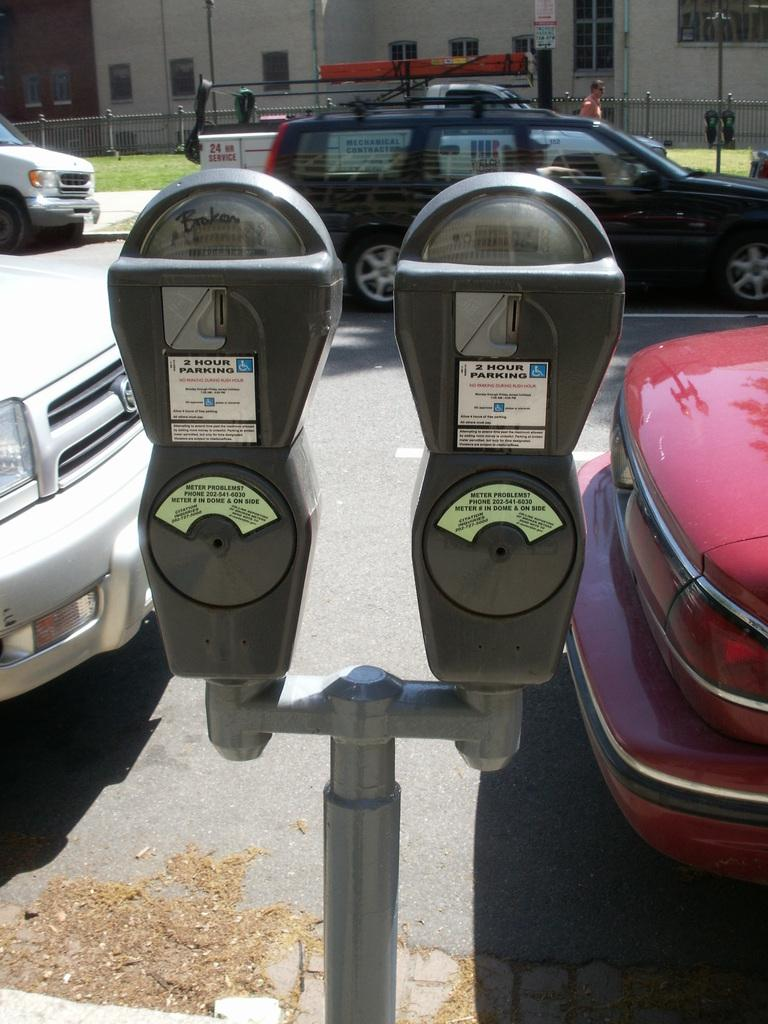<image>
Share a concise interpretation of the image provided. A pole with two parking meters on it with the left one reading that it is broken. 